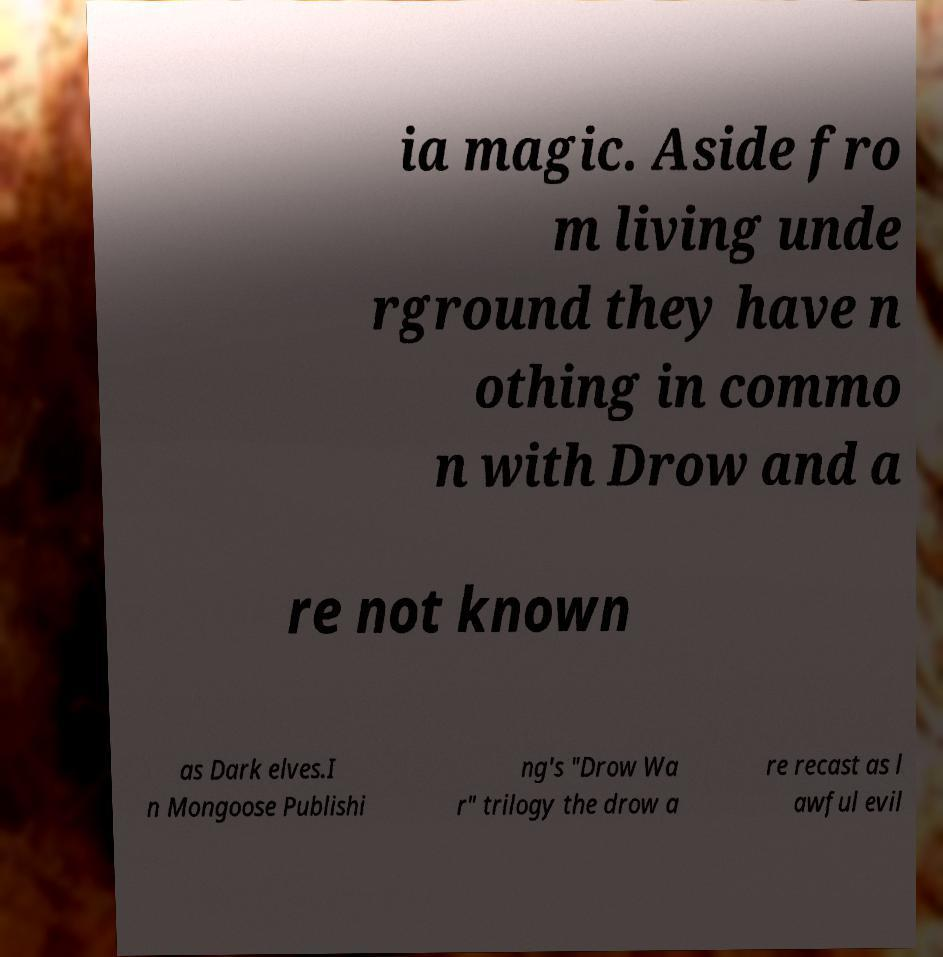Can you accurately transcribe the text from the provided image for me? ia magic. Aside fro m living unde rground they have n othing in commo n with Drow and a re not known as Dark elves.I n Mongoose Publishi ng's "Drow Wa r" trilogy the drow a re recast as l awful evil 